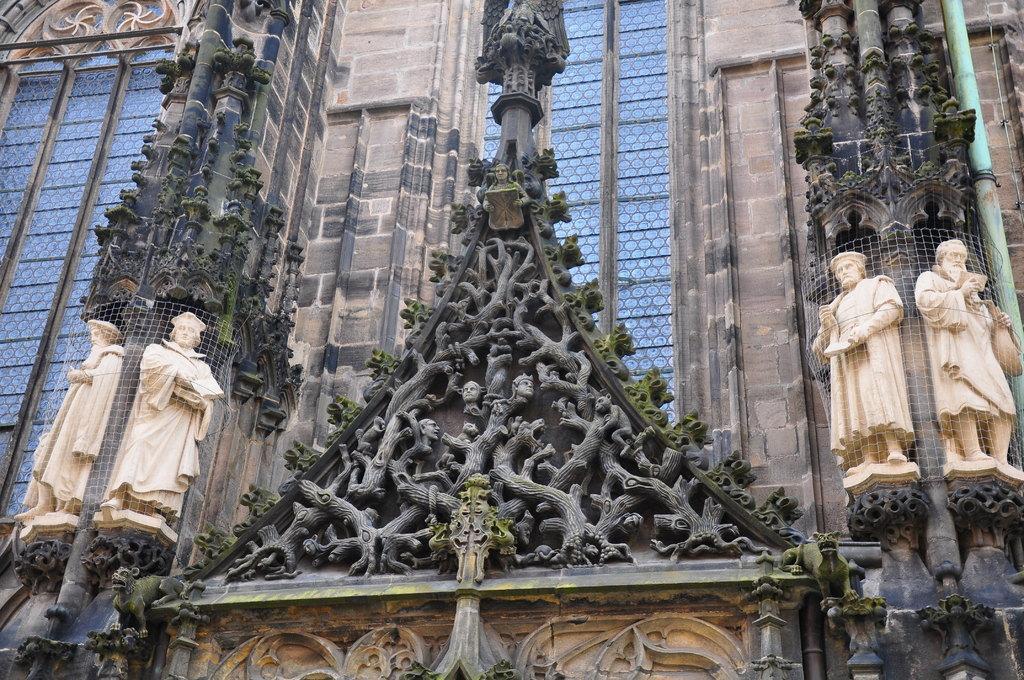Could you give a brief overview of what you see in this image? In this image there is a building having windows. There are sculptures on the wall. 